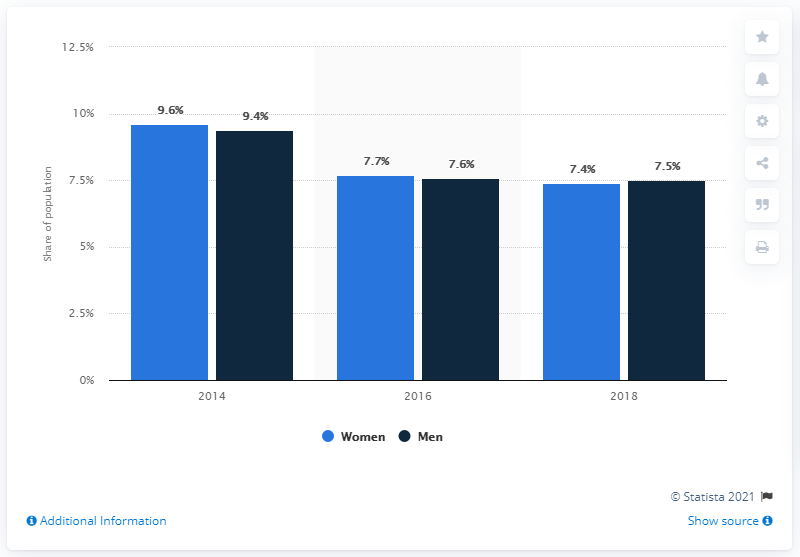Identify some key points in this picture. Men were more likely than women to experience extreme poverty, according to the data. 